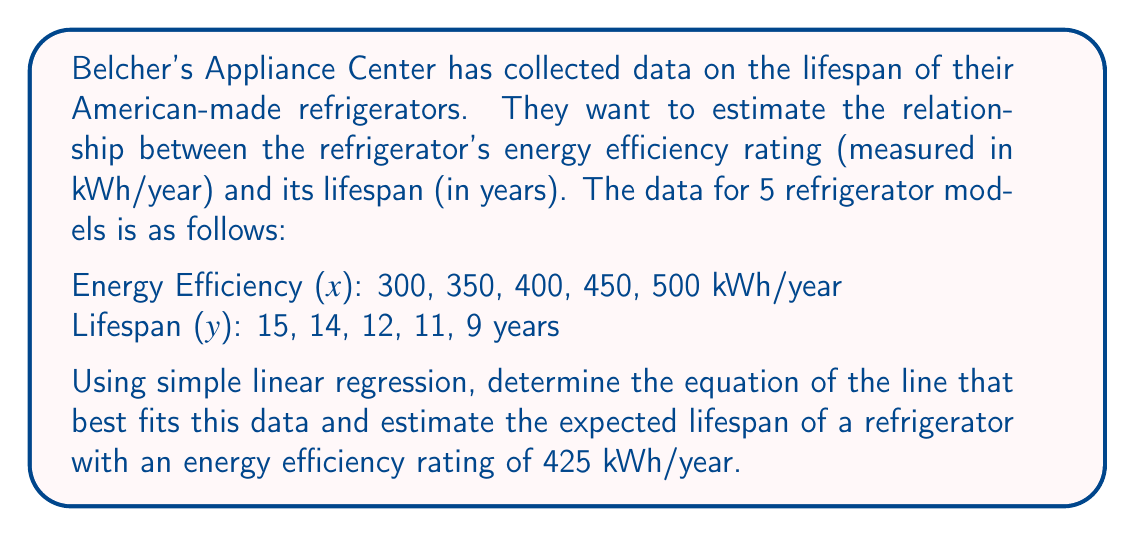Can you solve this math problem? To solve this problem, we'll use simple linear regression to find the line of best fit, then use that equation to estimate the lifespan of the refrigerator.

Step 1: Calculate the means of x and y
$\bar{x} = \frac{300 + 350 + 400 + 450 + 500}{5} = 400$
$\bar{y} = \frac{15 + 14 + 12 + 11 + 9}{5} = 12.2$

Step 2: Calculate the slope (b) using the formula:
$b = \frac{\sum(x_i - \bar{x})(y_i - \bar{y})}{\sum(x_i - \bar{x})^2}$

Let's calculate the numerator and denominator separately:

Numerator: $(-100)(2.8) + (-50)(1.8) + (0)(-0.2) + (50)(-1.2) + (100)(-3.2) = -620$
Denominator: $(-100)^2 + (-50)^2 + (0)^2 + (50)^2 + (100)^2 = 30,000$

$b = \frac{-620}{30,000} = -0.02067$

Step 3: Calculate the y-intercept (a) using the formula:
$a = \bar{y} - b\bar{x}$

$a = 12.2 - (-0.02067)(400) = 20.467$

Step 4: Write the equation of the line
$y = -0.02067x + 20.467$

Step 5: Estimate the lifespan for a refrigerator with 425 kWh/year efficiency
$y = -0.02067(425) + 20.467 = 11.68$ years
Answer: The equation of the line of best fit is $y = -0.02067x + 20.467$, where $x$ is the energy efficiency in kWh/year and $y$ is the estimated lifespan in years. The expected lifespan of a refrigerator with an energy efficiency rating of 425 kWh/year is approximately 11.68 years. 